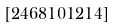<formula> <loc_0><loc_0><loc_500><loc_500>[ 2 4 6 8 1 0 1 2 1 4 ]</formula> 